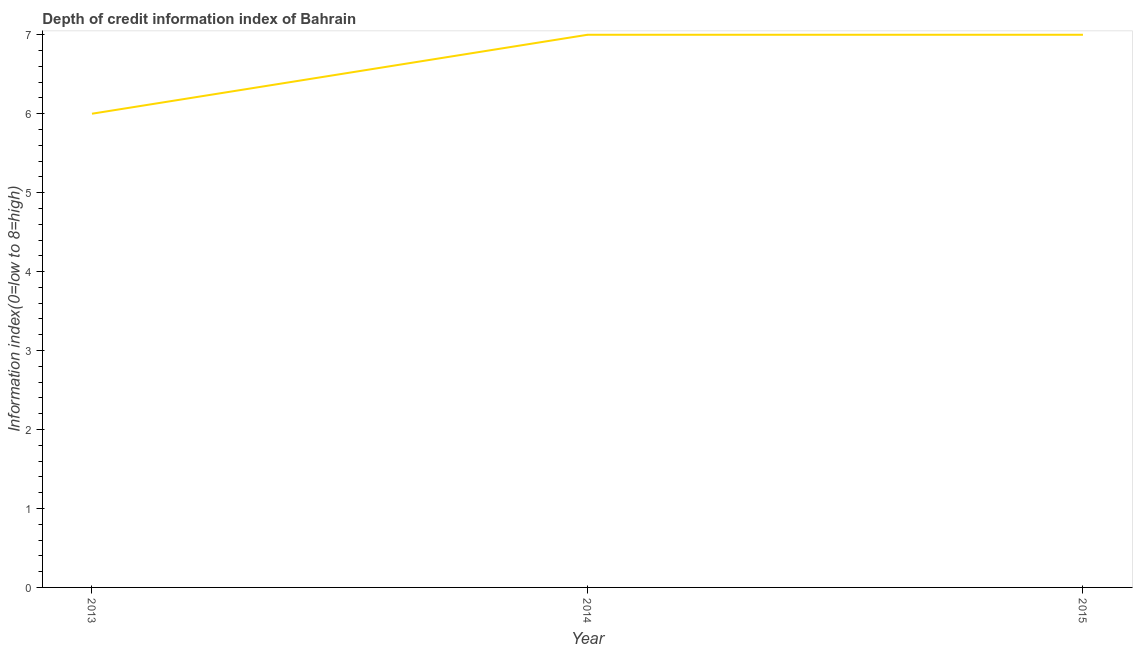Across all years, what is the maximum depth of credit information index?
Your response must be concise. 7. Across all years, what is the minimum depth of credit information index?
Ensure brevity in your answer.  6. What is the sum of the depth of credit information index?
Your answer should be very brief. 20. What is the difference between the depth of credit information index in 2013 and 2014?
Provide a short and direct response. -1. What is the average depth of credit information index per year?
Make the answer very short. 6.67. What is the ratio of the depth of credit information index in 2013 to that in 2015?
Provide a succinct answer. 0.86. Is the difference between the depth of credit information index in 2013 and 2014 greater than the difference between any two years?
Your response must be concise. Yes. What is the difference between the highest and the second highest depth of credit information index?
Your answer should be compact. 0. Is the sum of the depth of credit information index in 2013 and 2015 greater than the maximum depth of credit information index across all years?
Make the answer very short. Yes. What is the difference between the highest and the lowest depth of credit information index?
Your answer should be compact. 1. Does the depth of credit information index monotonically increase over the years?
Ensure brevity in your answer.  No. How many lines are there?
Make the answer very short. 1. How many years are there in the graph?
Ensure brevity in your answer.  3. What is the difference between two consecutive major ticks on the Y-axis?
Ensure brevity in your answer.  1. What is the title of the graph?
Provide a succinct answer. Depth of credit information index of Bahrain. What is the label or title of the X-axis?
Your answer should be very brief. Year. What is the label or title of the Y-axis?
Your response must be concise. Information index(0=low to 8=high). What is the Information index(0=low to 8=high) in 2013?
Offer a very short reply. 6. What is the Information index(0=low to 8=high) in 2014?
Ensure brevity in your answer.  7. What is the Information index(0=low to 8=high) in 2015?
Give a very brief answer. 7. What is the difference between the Information index(0=low to 8=high) in 2013 and 2014?
Keep it short and to the point. -1. What is the difference between the Information index(0=low to 8=high) in 2013 and 2015?
Provide a short and direct response. -1. What is the difference between the Information index(0=low to 8=high) in 2014 and 2015?
Provide a short and direct response. 0. What is the ratio of the Information index(0=low to 8=high) in 2013 to that in 2014?
Offer a very short reply. 0.86. What is the ratio of the Information index(0=low to 8=high) in 2013 to that in 2015?
Make the answer very short. 0.86. What is the ratio of the Information index(0=low to 8=high) in 2014 to that in 2015?
Offer a very short reply. 1. 